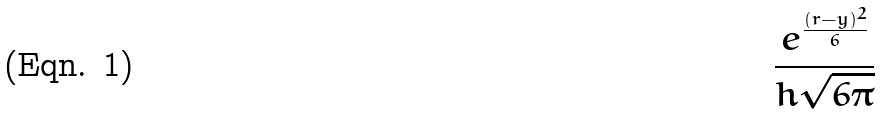Convert formula to latex. <formula><loc_0><loc_0><loc_500><loc_500>\frac { e ^ { \frac { ( r - y ) ^ { 2 } } { 6 } } } { h \sqrt { 6 \pi } }</formula> 